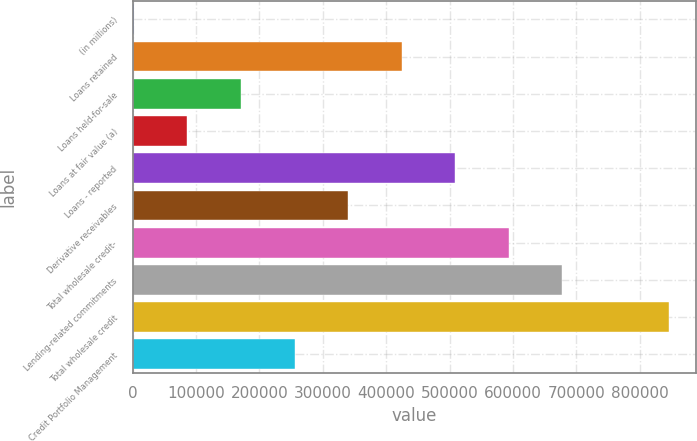Convert chart. <chart><loc_0><loc_0><loc_500><loc_500><bar_chart><fcel>(in millions)<fcel>Loans retained<fcel>Loans held-for-sale<fcel>Loans at fair value (a)<fcel>Loans - reported<fcel>Derivative receivables<fcel>Total wholesale credit-<fcel>Lending-related commitments<fcel>Total wholesale credit<fcel>Credit Portfolio Management<nl><fcel>2012<fcel>424320<fcel>170935<fcel>86473.6<fcel>508782<fcel>339858<fcel>593243<fcel>677705<fcel>846628<fcel>255397<nl></chart> 